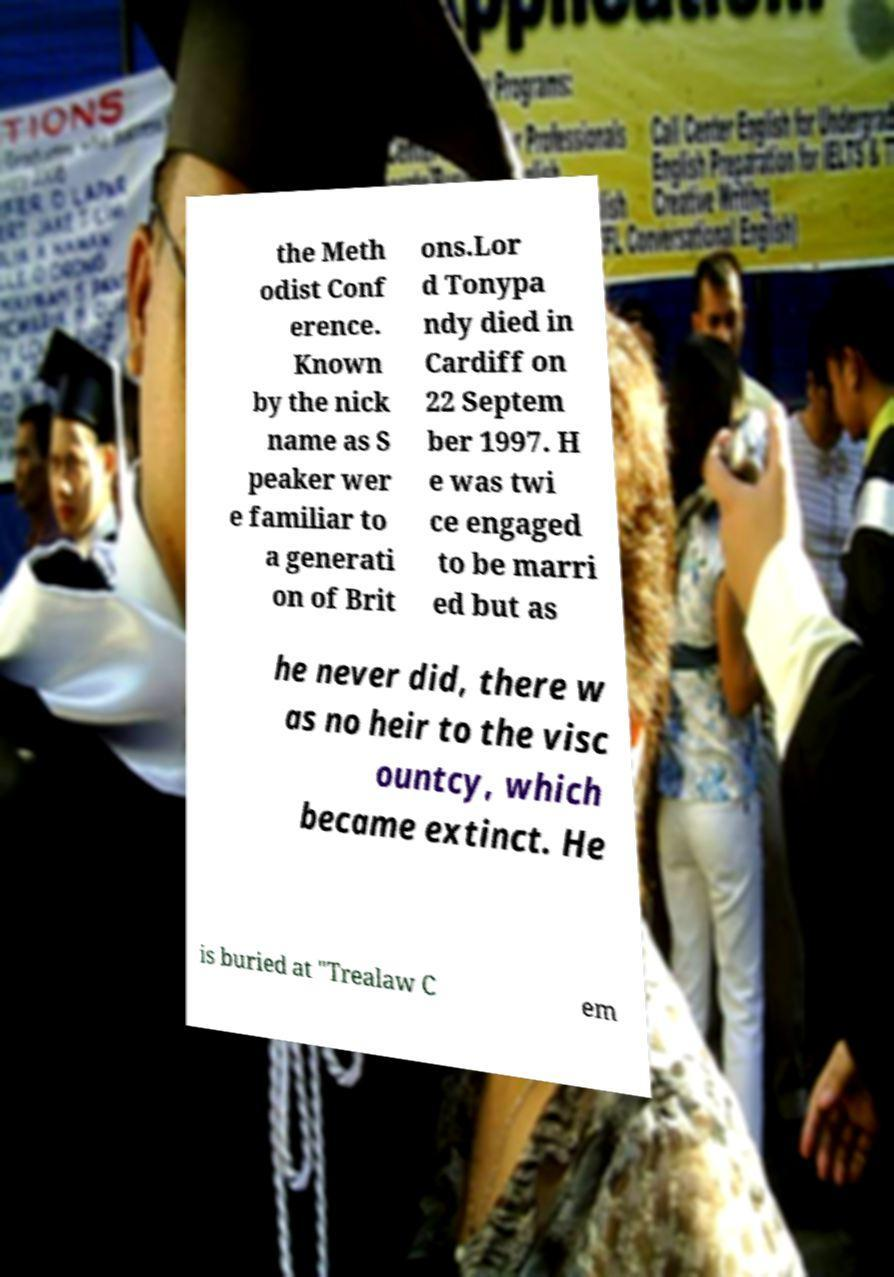Could you extract and type out the text from this image? the Meth odist Conf erence. Known by the nick name as S peaker wer e familiar to a generati on of Brit ons.Lor d Tonypa ndy died in Cardiff on 22 Septem ber 1997. H e was twi ce engaged to be marri ed but as he never did, there w as no heir to the visc ountcy, which became extinct. He is buried at "Trealaw C em 